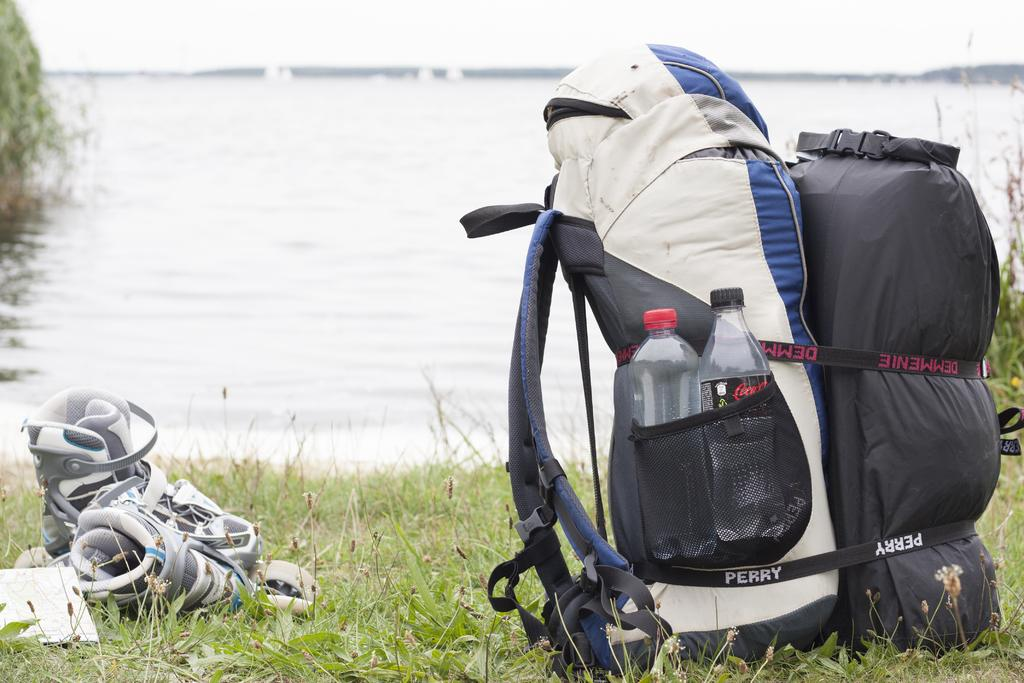<image>
Render a clear and concise summary of the photo. A large backpack sits on the grass by the water made by the company Perry. 